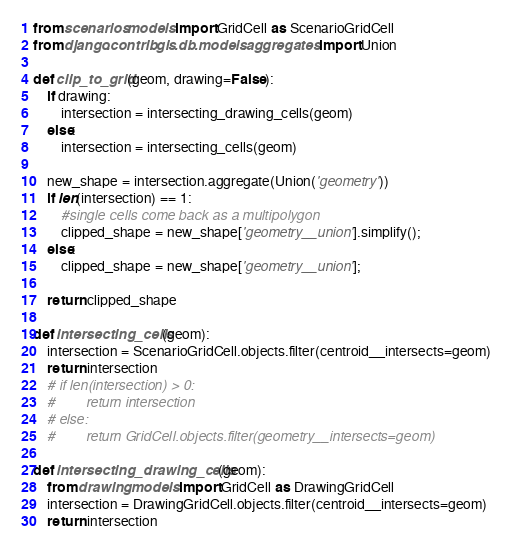Convert code to text. <code><loc_0><loc_0><loc_500><loc_500><_Python_>from scenarios.models import GridCell as ScenarioGridCell
from django.contrib.gis.db.models.aggregates import Union

def clip_to_grid(geom, drawing=False):
    if drawing:
        intersection = intersecting_drawing_cells(geom)
    else:
        intersection = intersecting_cells(geom)

    new_shape = intersection.aggregate(Union('geometry'))
    if len(intersection) == 1:
        #single cells come back as a multipolygon
        clipped_shape = new_shape['geometry__union'].simplify();
    else:
        clipped_shape = new_shape['geometry__union'];

    return clipped_shape

def intersecting_cells(geom):
    intersection = ScenarioGridCell.objects.filter(centroid__intersects=geom)
    return intersection
    # if len(intersection) > 0:
	#        return intersection
    # else:
	#        return GridCell.objects.filter(geometry__intersects=geom)

def intersecting_drawing_cells(geom):
    from drawing.models import GridCell as DrawingGridCell
    intersection = DrawingGridCell.objects.filter(centroid__intersects=geom)
    return intersection
</code> 